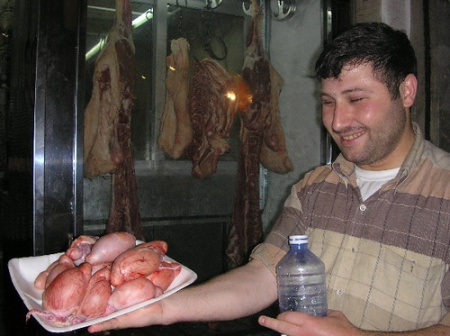What might the setting tell us about the cultural significance of meat in this context? The setting, with its attention to showcasing the meats both raw and processed, suggests a cultural environment where meat is not only a staple food but perhaps also a point of pride. This may indicate a locale where artisan butchery and meat processing are cherished cultural practices, perhaps in a region renowned for its meat production and culinary expertise. The care in display and the variety of meats can also highlight local culinary traditions or festivals where such foods play a central role, symbolizing abundance and quality. 